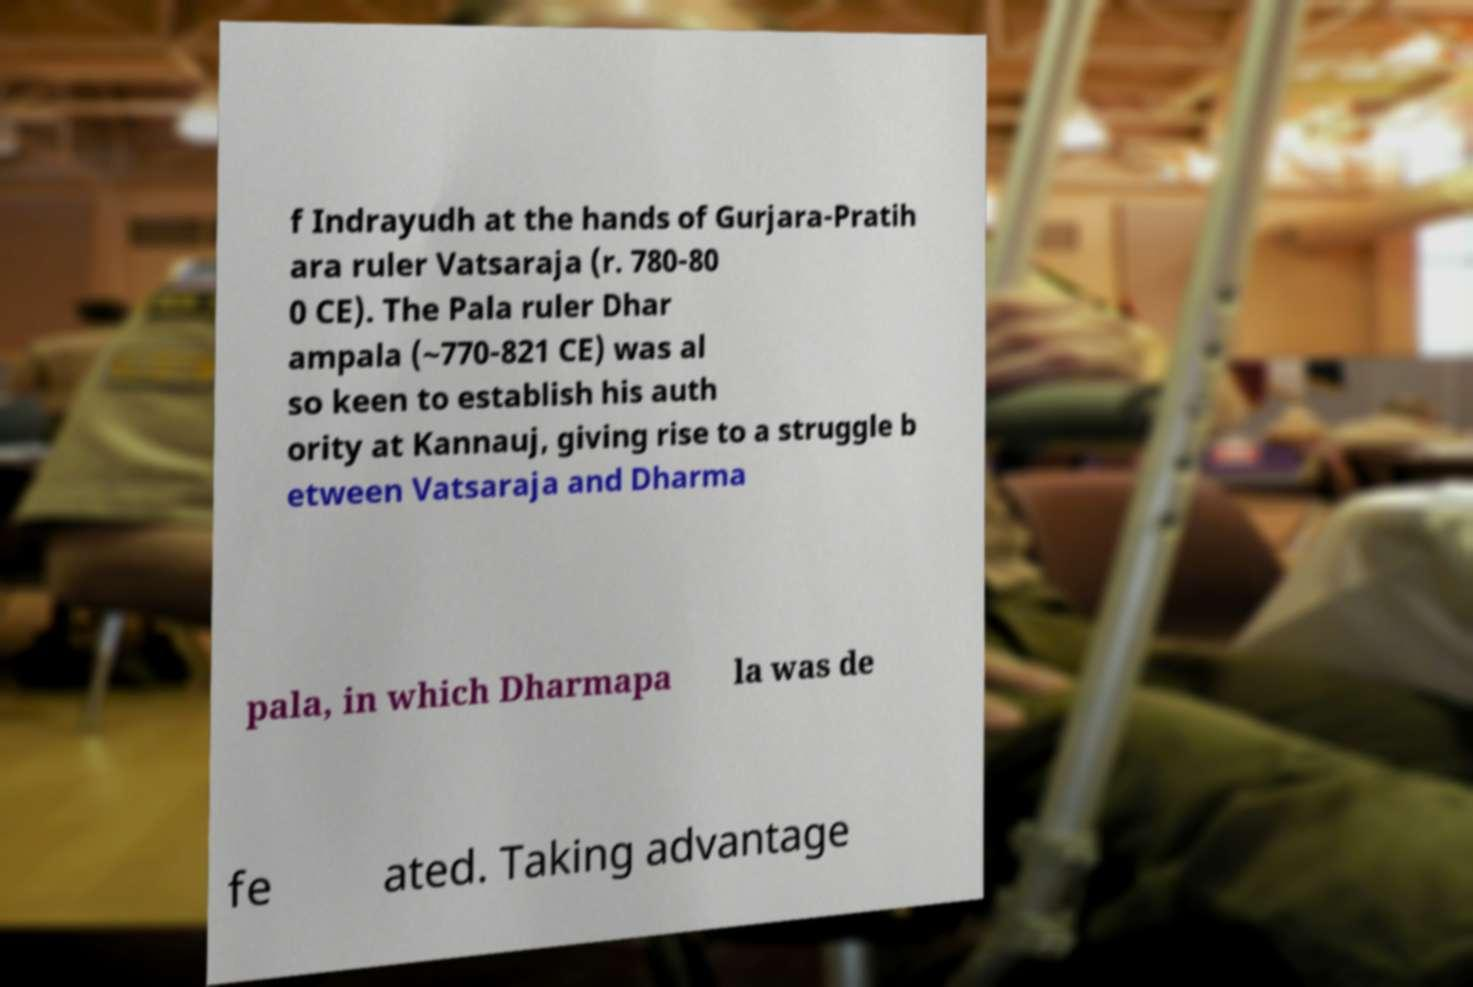Please read and relay the text visible in this image. What does it say? f Indrayudh at the hands of Gurjara-Pratih ara ruler Vatsaraja (r. 780-80 0 CE). The Pala ruler Dhar ampala (~770-821 CE) was al so keen to establish his auth ority at Kannauj, giving rise to a struggle b etween Vatsaraja and Dharma pala, in which Dharmapa la was de fe ated. Taking advantage 